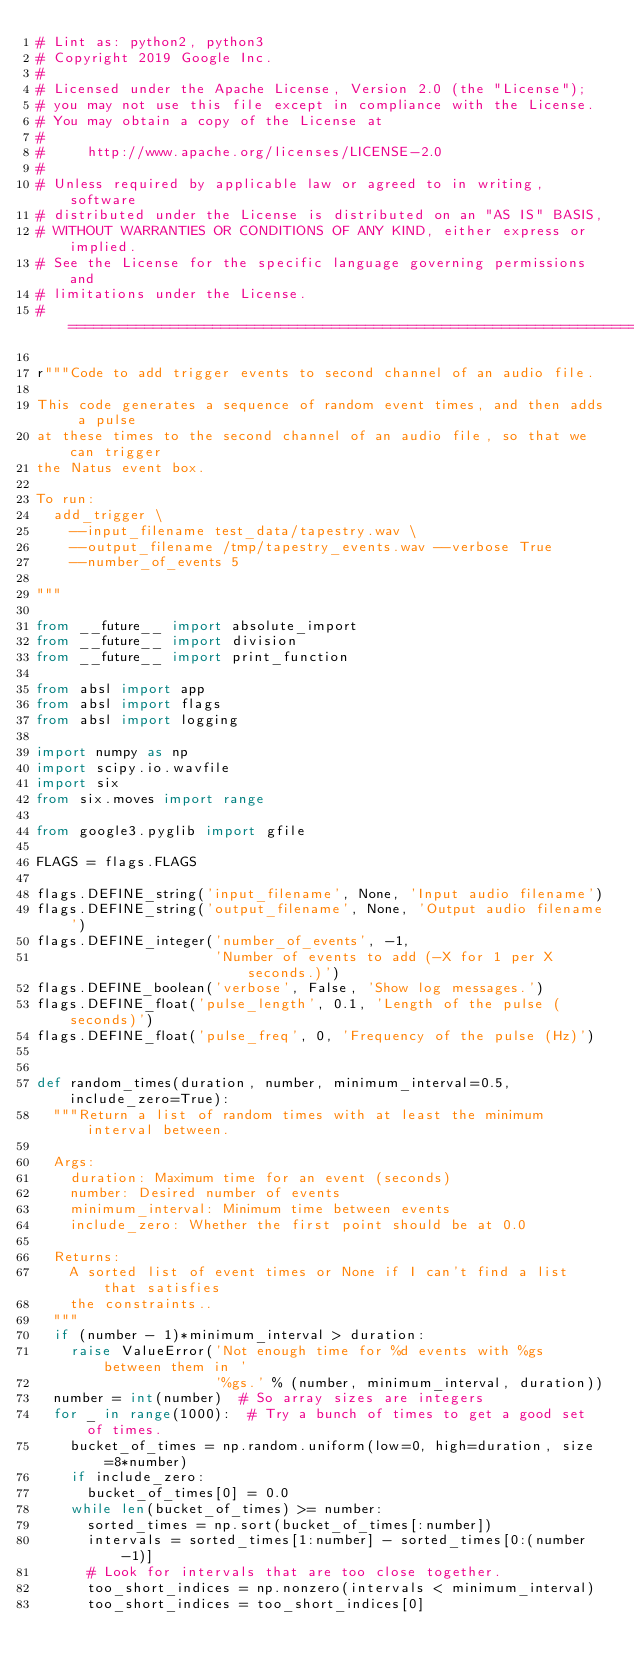Convert code to text. <code><loc_0><loc_0><loc_500><loc_500><_Python_># Lint as: python2, python3
# Copyright 2019 Google Inc.
#
# Licensed under the Apache License, Version 2.0 (the "License");
# you may not use this file except in compliance with the License.
# You may obtain a copy of the License at
#
#     http://www.apache.org/licenses/LICENSE-2.0
#
# Unless required by applicable law or agreed to in writing, software
# distributed under the License is distributed on an "AS IS" BASIS,
# WITHOUT WARRANTIES OR CONDITIONS OF ANY KIND, either express or implied.
# See the License for the specific language governing permissions and
# limitations under the License.
# ==============================================================================

r"""Code to add trigger events to second channel of an audio file.

This code generates a sequence of random event times, and then adds a pulse
at these times to the second channel of an audio file, so that we can trigger
the Natus event box.

To run:
  add_trigger \
    --input_filename test_data/tapestry.wav \
    --output_filename /tmp/tapestry_events.wav --verbose True
    --number_of_events 5

"""

from __future__ import absolute_import
from __future__ import division
from __future__ import print_function

from absl import app
from absl import flags
from absl import logging

import numpy as np
import scipy.io.wavfile
import six
from six.moves import range

from google3.pyglib import gfile

FLAGS = flags.FLAGS

flags.DEFINE_string('input_filename', None, 'Input audio filename')
flags.DEFINE_string('output_filename', None, 'Output audio filename')
flags.DEFINE_integer('number_of_events', -1,
                     'Number of events to add (-X for 1 per X seconds.)')
flags.DEFINE_boolean('verbose', False, 'Show log messages.')
flags.DEFINE_float('pulse_length', 0.1, 'Length of the pulse (seconds)')
flags.DEFINE_float('pulse_freq', 0, 'Frequency of the pulse (Hz)')


def random_times(duration, number, minimum_interval=0.5, include_zero=True):
  """Return a list of random times with at least the minimum interval between.

  Args:
    duration: Maximum time for an event (seconds)
    number: Desired number of events
    minimum_interval: Minimum time between events
    include_zero: Whether the first point should be at 0.0

  Returns:
    A sorted list of event times or None if I can't find a list that satisfies
    the constraints..
  """
  if (number - 1)*minimum_interval > duration:
    raise ValueError('Not enough time for %d events with %gs between them in '
                     '%gs.' % (number, minimum_interval, duration))
  number = int(number)  # So array sizes are integers
  for _ in range(1000):  # Try a bunch of times to get a good set of times.
    bucket_of_times = np.random.uniform(low=0, high=duration, size=8*number)
    if include_zero:
      bucket_of_times[0] = 0.0
    while len(bucket_of_times) >= number:
      sorted_times = np.sort(bucket_of_times[:number])
      intervals = sorted_times[1:number] - sorted_times[0:(number-1)]
      # Look for intervals that are too close together.
      too_short_indices = np.nonzero(intervals < minimum_interval)
      too_short_indices = too_short_indices[0]</code> 